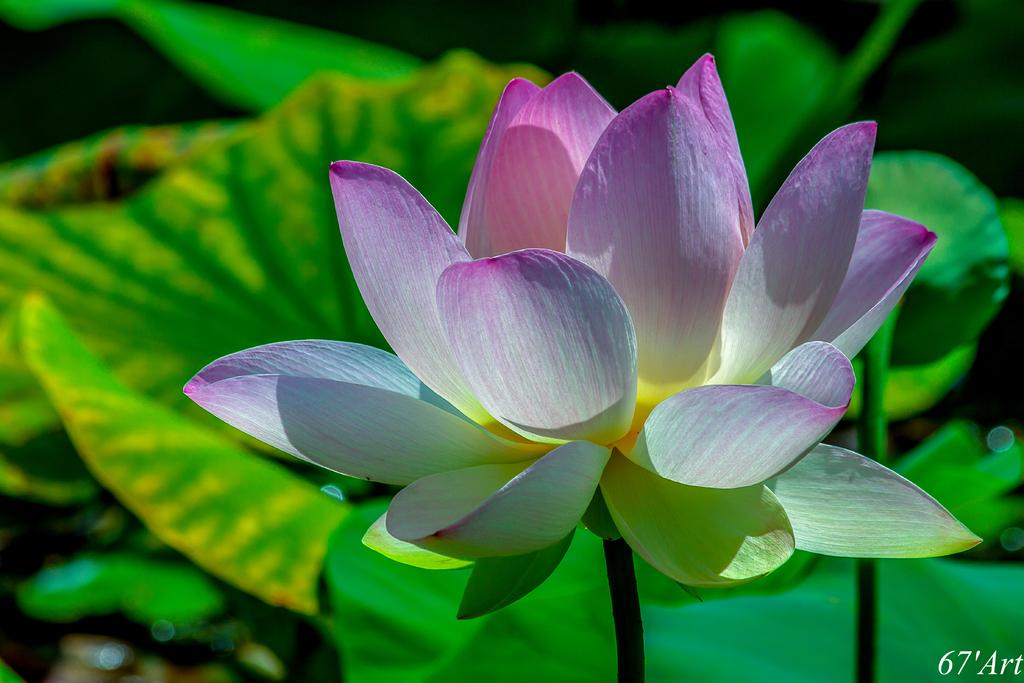What is the main subject of the image? There is a lotus flower in the image. What can be seen behind the lotus flower? There are plants with leaves behind the lotus flower. Can you see a baby playing with the lotus flower in the image? A: There is no baby present in the image, and the lotus flower is not being played with. 